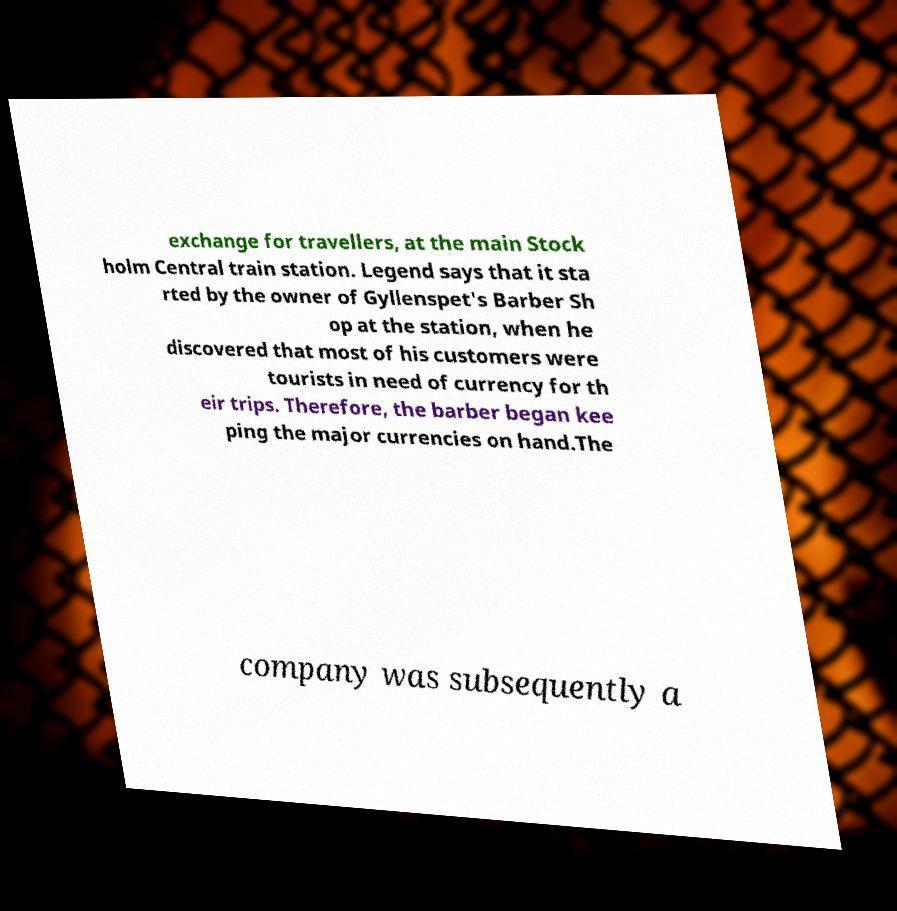Please read and relay the text visible in this image. What does it say? exchange for travellers, at the main Stock holm Central train station. Legend says that it sta rted by the owner of Gyllenspet's Barber Sh op at the station, when he discovered that most of his customers were tourists in need of currency for th eir trips. Therefore, the barber began kee ping the major currencies on hand.The company was subsequently a 